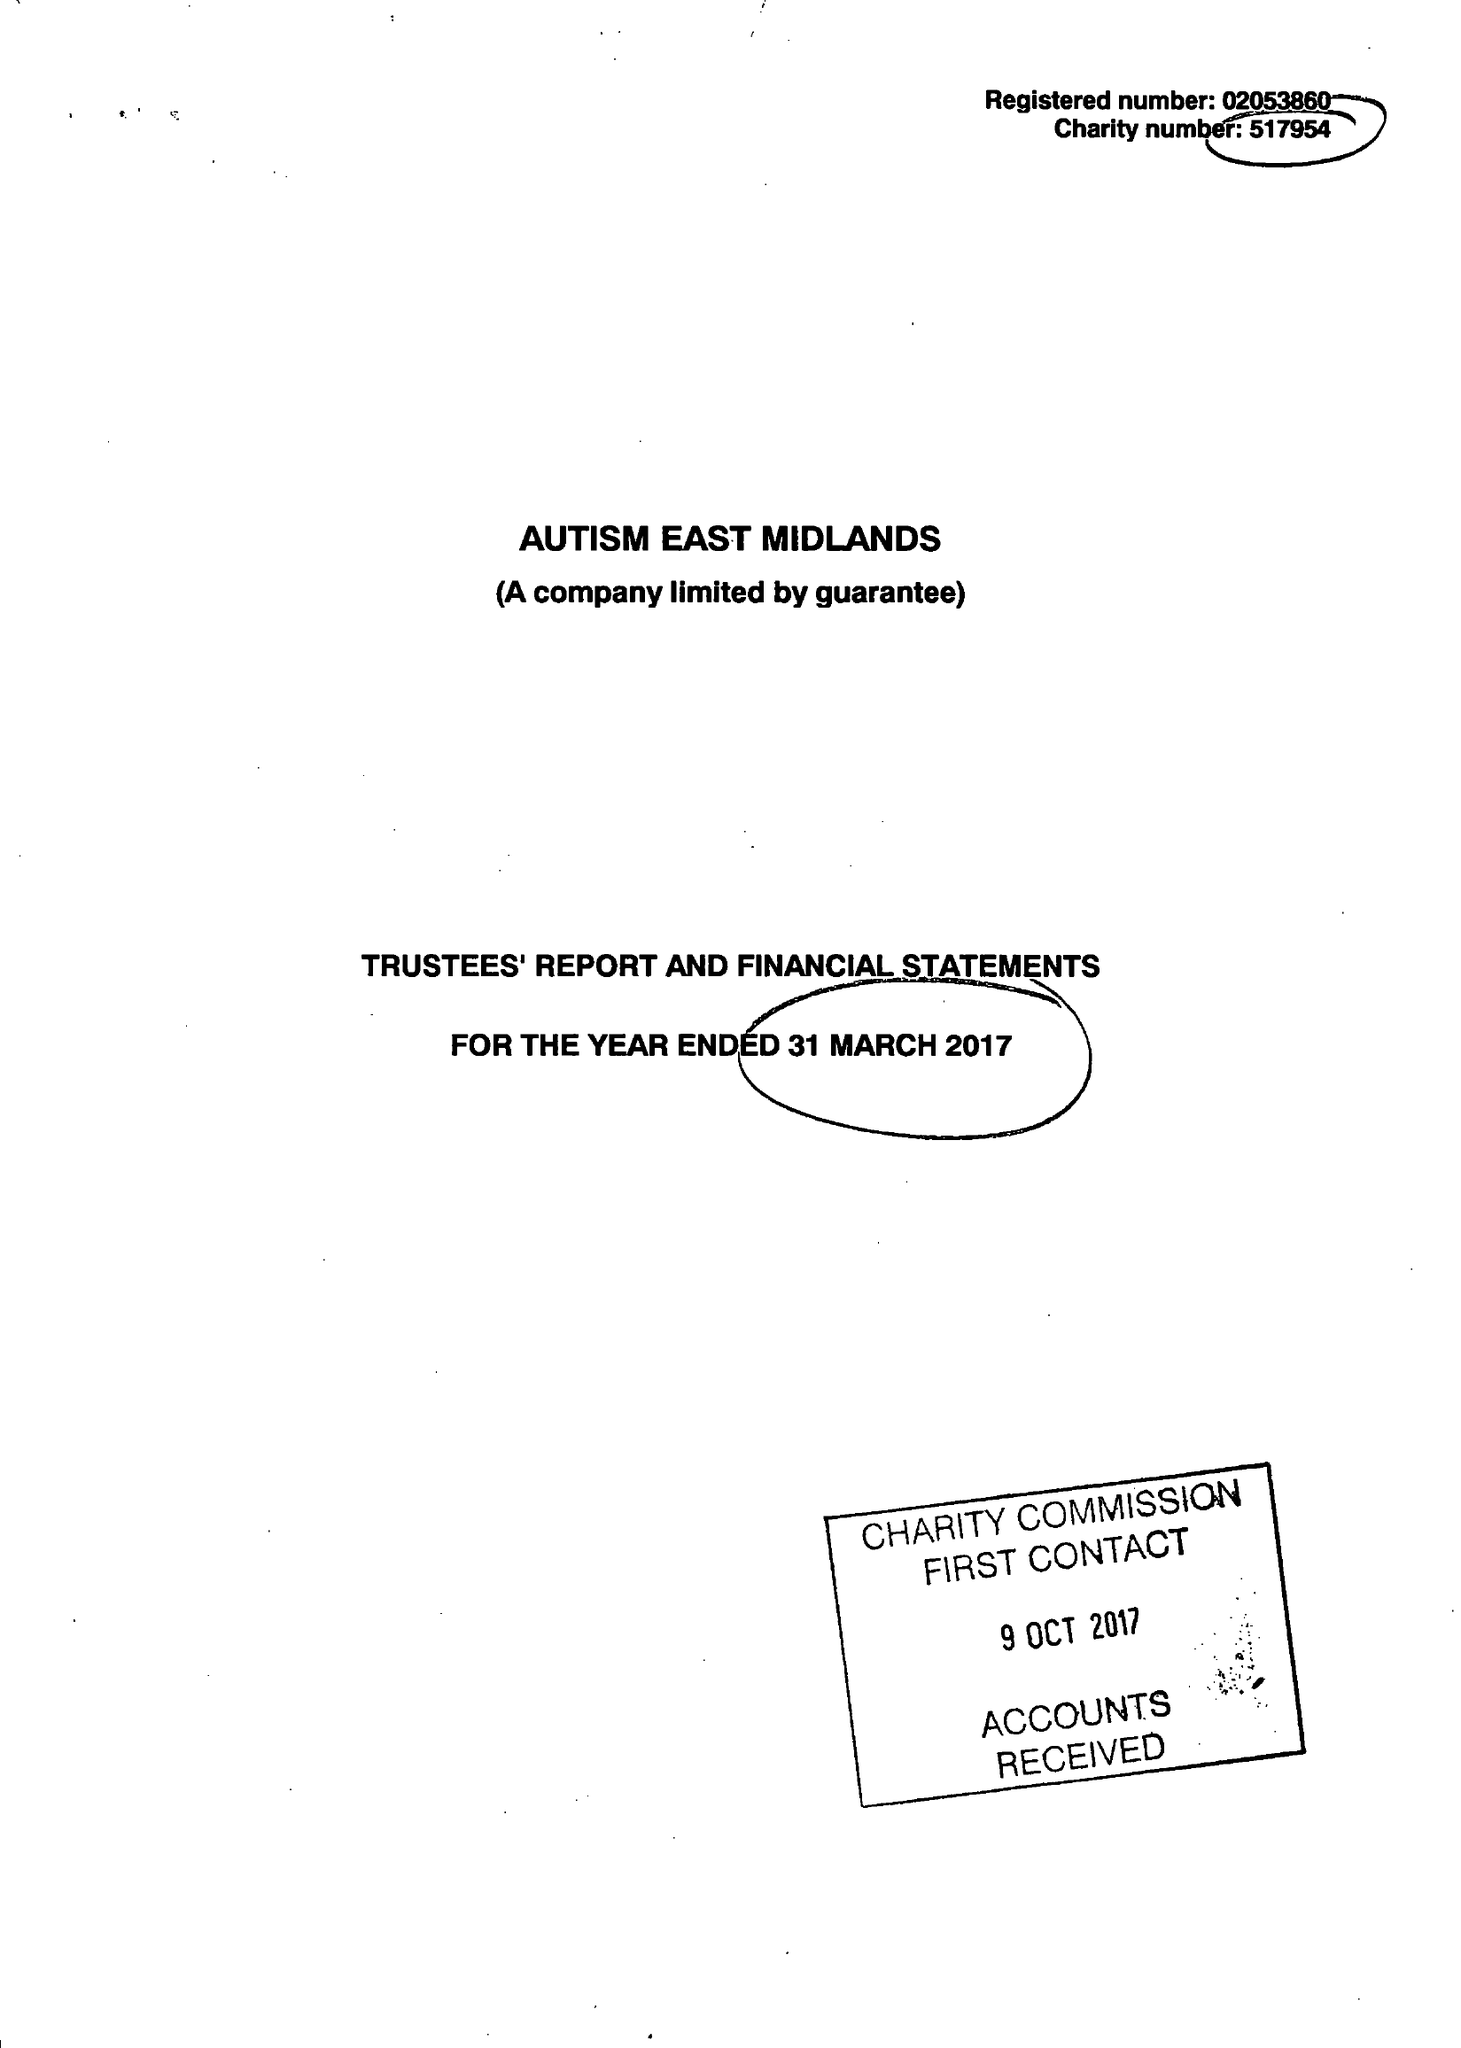What is the value for the charity_number?
Answer the question using a single word or phrase. 517954 